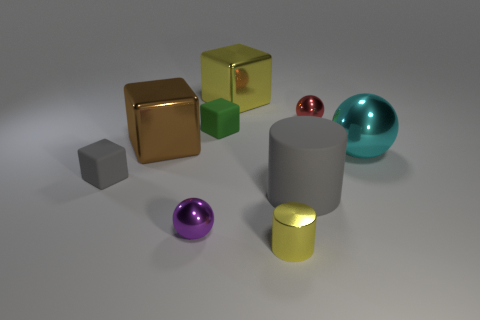Subtract all balls. How many objects are left? 6 Add 5 large cyan things. How many large cyan things exist? 6 Subtract 1 brown cubes. How many objects are left? 8 Subtract all small brown things. Subtract all red metallic spheres. How many objects are left? 8 Add 5 brown metal cubes. How many brown metal cubes are left? 6 